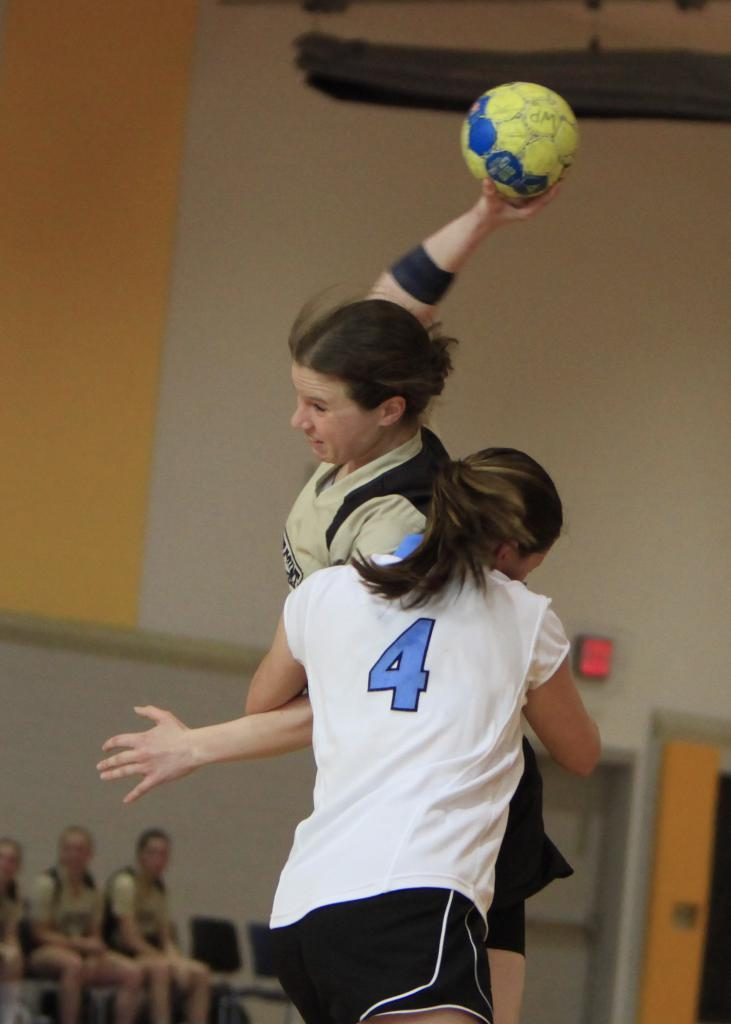<image>
Share a concise interpretation of the image provided. Two women playing sports, one with a white shirt with a blue number four on it. 